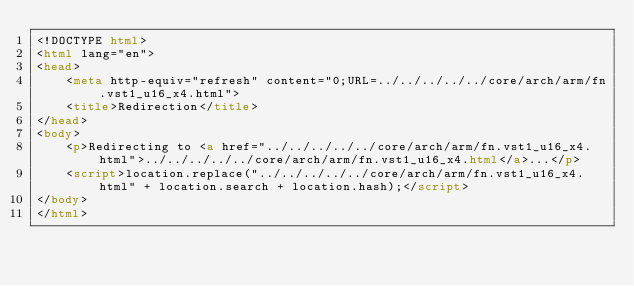<code> <loc_0><loc_0><loc_500><loc_500><_HTML_><!DOCTYPE html>
<html lang="en">
<head>
    <meta http-equiv="refresh" content="0;URL=../../../../../core/arch/arm/fn.vst1_u16_x4.html">
    <title>Redirection</title>
</head>
<body>
    <p>Redirecting to <a href="../../../../../core/arch/arm/fn.vst1_u16_x4.html">../../../../../core/arch/arm/fn.vst1_u16_x4.html</a>...</p>
    <script>location.replace("../../../../../core/arch/arm/fn.vst1_u16_x4.html" + location.search + location.hash);</script>
</body>
</html></code> 